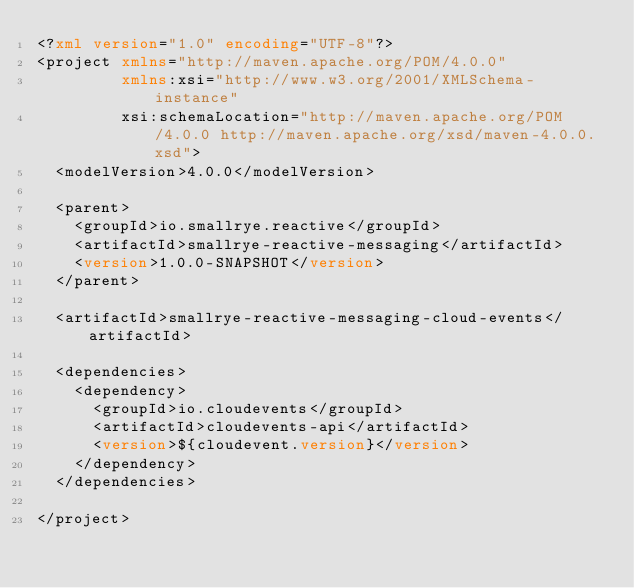Convert code to text. <code><loc_0><loc_0><loc_500><loc_500><_XML_><?xml version="1.0" encoding="UTF-8"?>
<project xmlns="http://maven.apache.org/POM/4.0.0"
         xmlns:xsi="http://www.w3.org/2001/XMLSchema-instance"
         xsi:schemaLocation="http://maven.apache.org/POM/4.0.0 http://maven.apache.org/xsd/maven-4.0.0.xsd">
  <modelVersion>4.0.0</modelVersion>

  <parent>
    <groupId>io.smallrye.reactive</groupId>
    <artifactId>smallrye-reactive-messaging</artifactId>
    <version>1.0.0-SNAPSHOT</version>
  </parent>

  <artifactId>smallrye-reactive-messaging-cloud-events</artifactId>

  <dependencies>
    <dependency>
      <groupId>io.cloudevents</groupId>
      <artifactId>cloudevents-api</artifactId>
      <version>${cloudevent.version}</version>
    </dependency>
  </dependencies>

</project>
</code> 